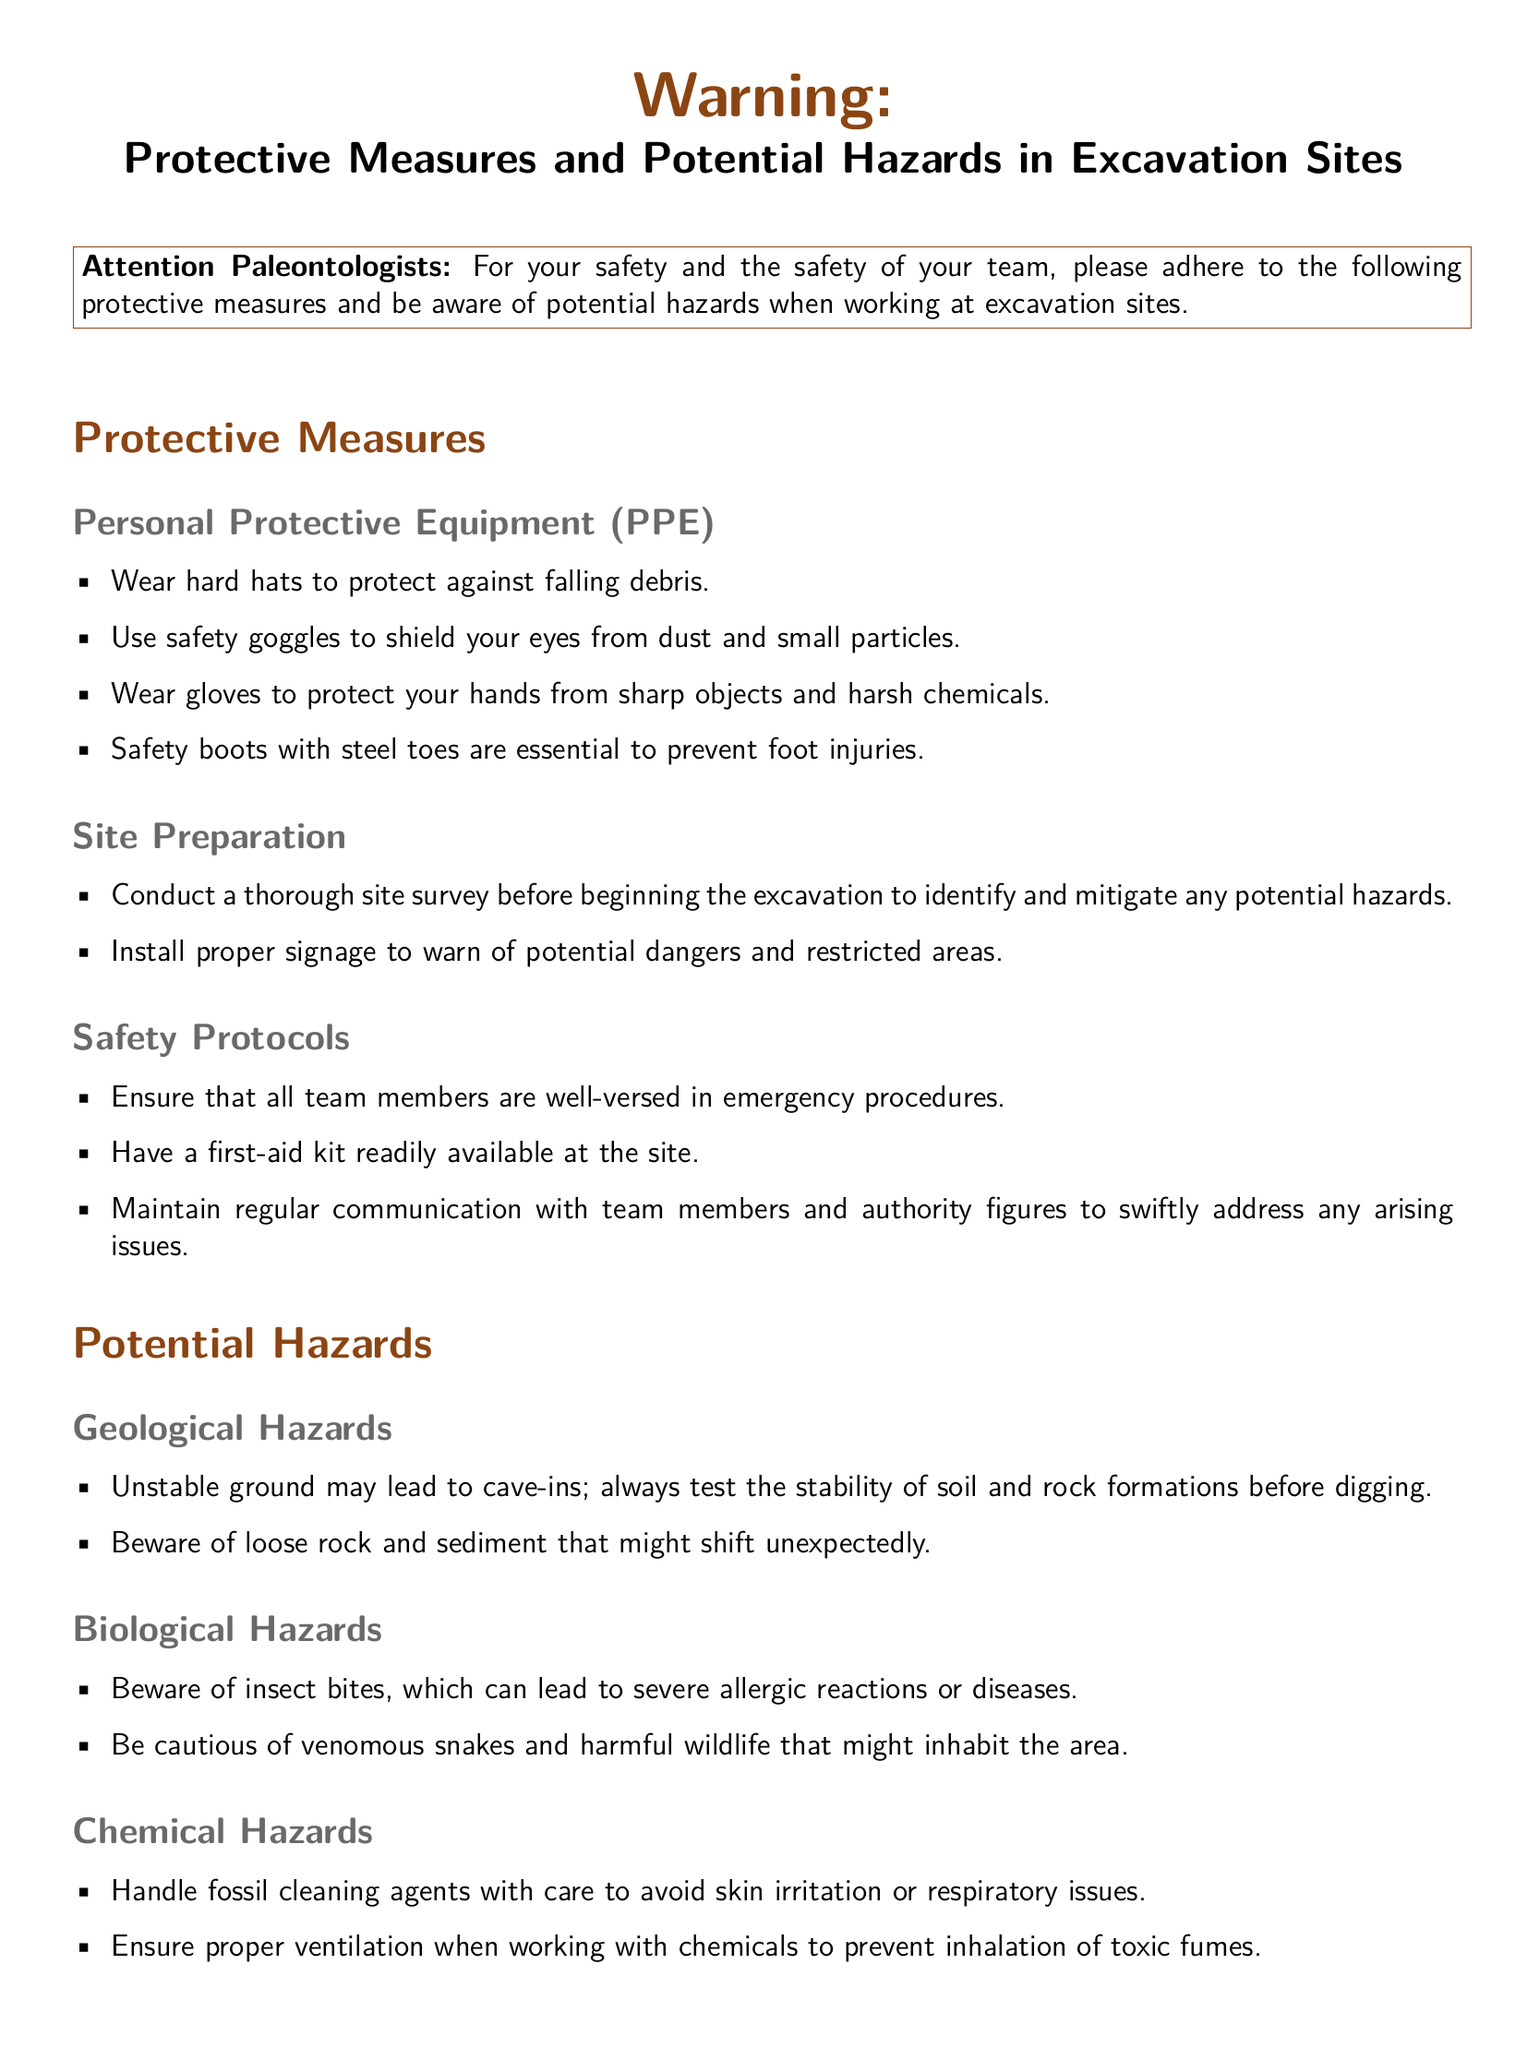What should you wear to protect your head? The document specifies that hard hats should be worn to protect against falling debris.
Answer: hard hats What is one example of personal protective equipment? The document lists several items, including safety goggles, which are classified as personal protective equipment.
Answer: safety goggles What should you do before starting excavation? The document states that conducting a thorough site survey is a necessary step before starting excavation.
Answer: site survey What type of hazard is related to underground power lines? The document identifies electrical hazards as the concern regarding underground power lines.
Answer: electrical hazards What should you maintain among team members? The document emphasizes the need for regular communication among team members to address any issues.
Answer: regular communication How should you handle fossil cleaning agents? According to the document, fossil cleaning agents should be handled with care to avoid skin irritation.
Answer: with care What might unstable ground lead to? The document warns that unstable ground may lead to cave-ins.
Answer: cave-ins Which biological hazard should you be cautious of? The document highlights venomous snakes as a biological hazard to be cautious of.
Answer: venomous snakes What type of boots should you wear? The document states that safety boots with steel toes are essential for foot injury prevention.
Answer: safety boots with steel toes 